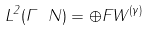<formula> <loc_0><loc_0><loc_500><loc_500>L ^ { 2 } ( \Gamma \ N ) = \oplus F W ^ { ( \gamma ) }</formula> 